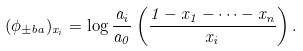Convert formula to latex. <formula><loc_0><loc_0><loc_500><loc_500>( \phi _ { \pm b { a } } ) _ { x _ { i } } = \log \frac { a _ { i } } { a _ { 0 } } \left ( \frac { 1 - x _ { 1 } - \cdots - x _ { n } } { x _ { i } } \right ) .</formula> 